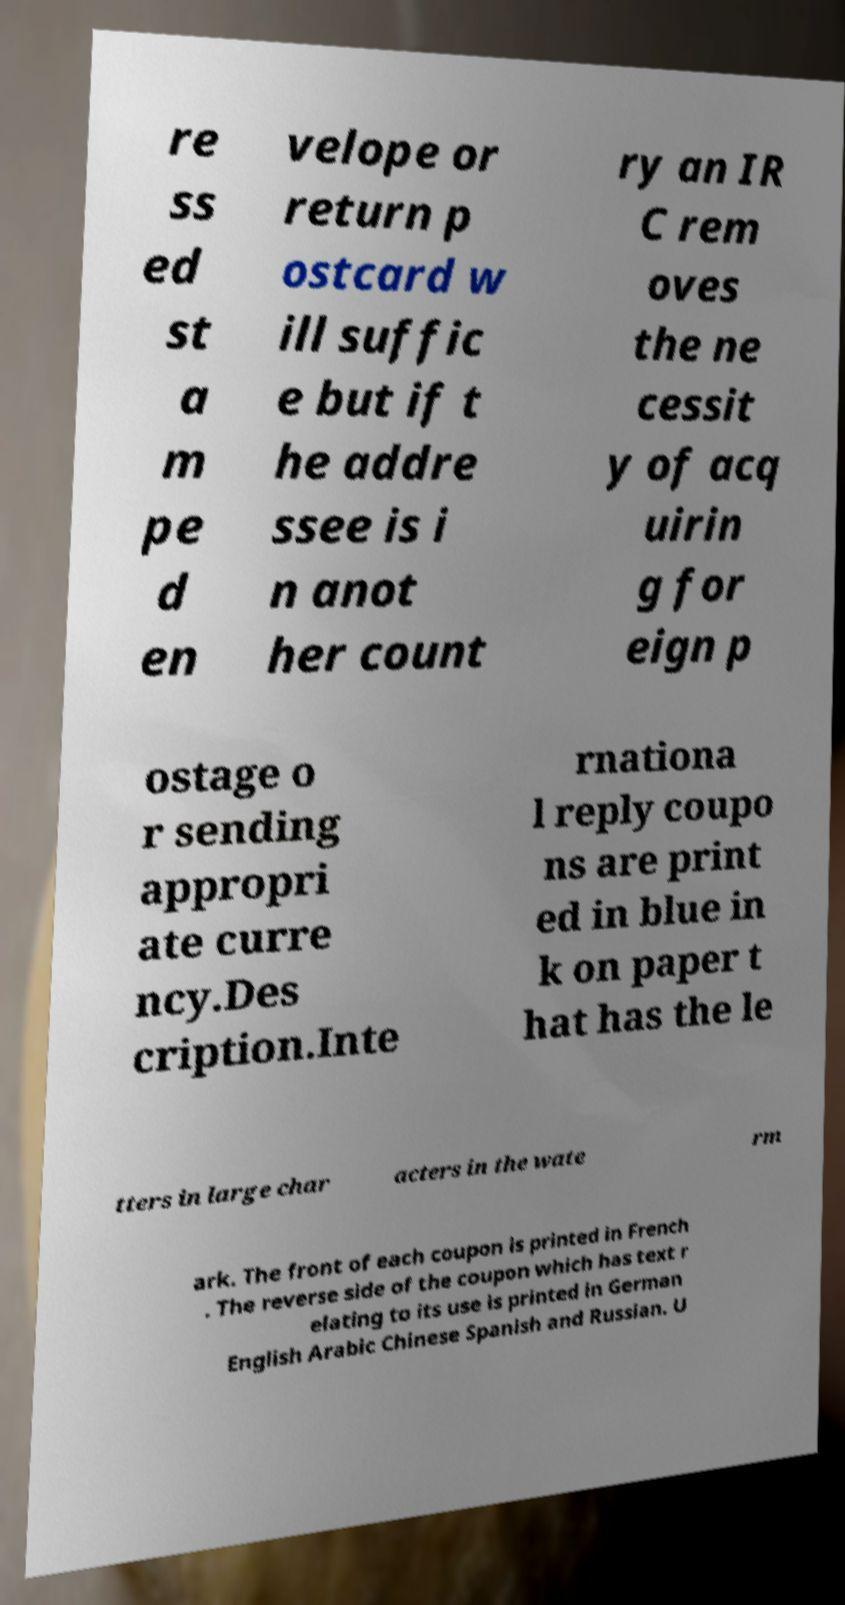Could you assist in decoding the text presented in this image and type it out clearly? re ss ed st a m pe d en velope or return p ostcard w ill suffic e but if t he addre ssee is i n anot her count ry an IR C rem oves the ne cessit y of acq uirin g for eign p ostage o r sending appropri ate curre ncy.Des cription.Inte rnationa l reply coupo ns are print ed in blue in k on paper t hat has the le tters in large char acters in the wate rm ark. The front of each coupon is printed in French . The reverse side of the coupon which has text r elating to its use is printed in German English Arabic Chinese Spanish and Russian. U 